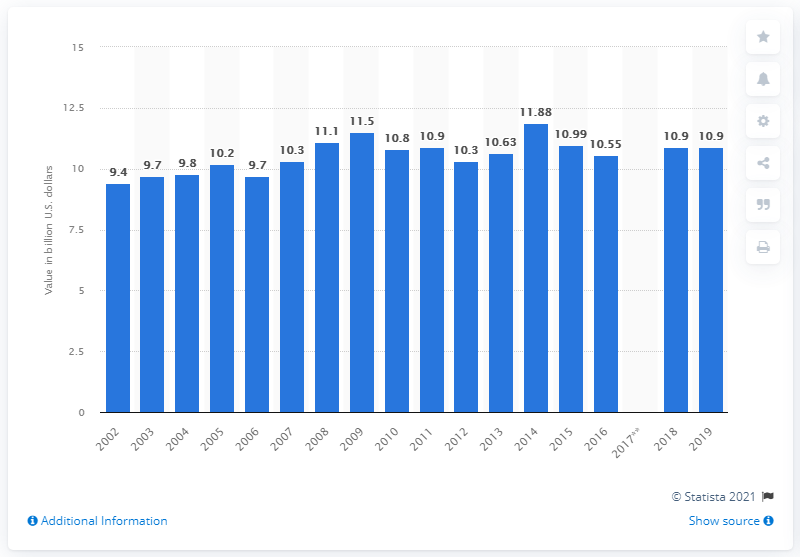Indicate a few pertinent items in this graphic. In 2019, the value of cookies and crackers shipped in the United States was approximately $10.9 billion. 